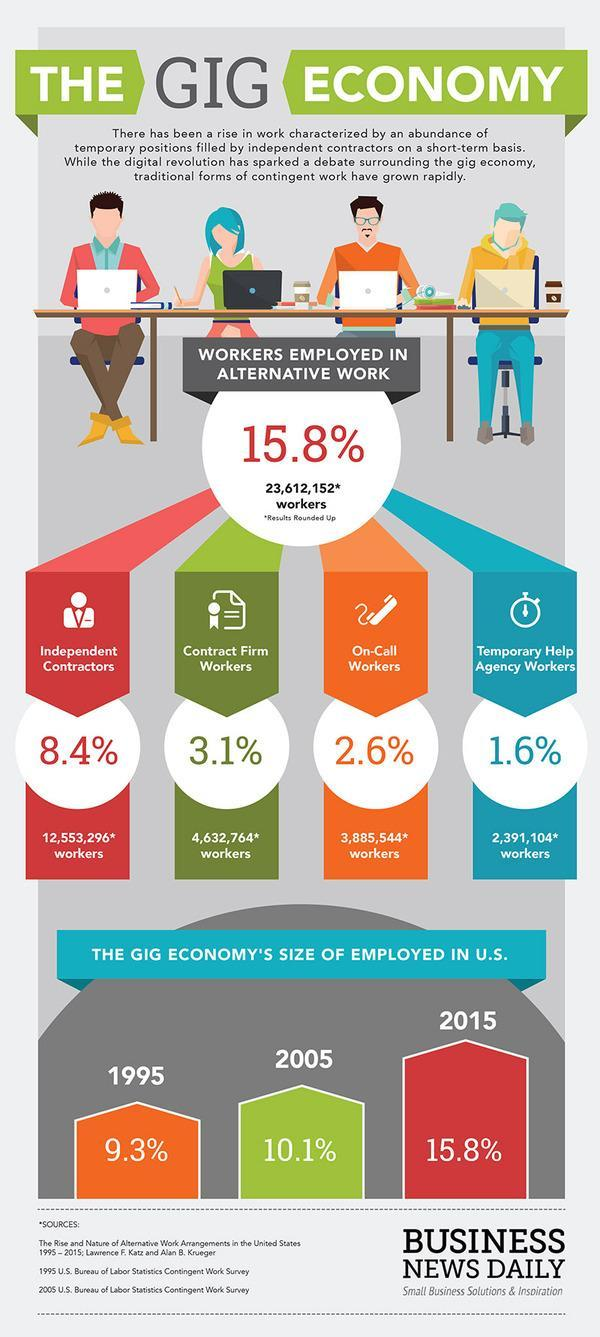what is the approximate number of independent contractors?
Answer the question with a short phrase. 12553296 what is the approximate number of contract form workers? 4632764 what is the approximate number of on call workers? 3885544 which kind of workers dominates the gig economy? independent contractors 